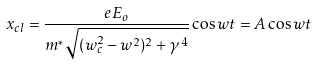Convert formula to latex. <formula><loc_0><loc_0><loc_500><loc_500>x _ { c l } = \frac { e E _ { o } } { m ^ { * } \sqrt { ( w _ { c } ^ { 2 } - w ^ { 2 } ) ^ { 2 } + \gamma ^ { 4 } } } \cos w t = A \cos w t</formula> 